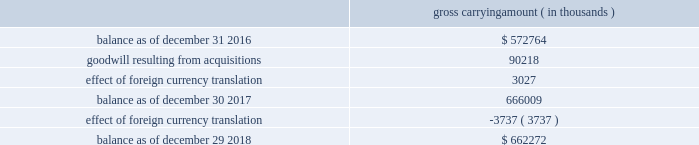Note 8 .
Acquisitions during fiscal 2017 , cadence completed two business combinations for total cash consideration of $ 142.8 million , after taking into account cash acquired of $ 4.2 million .
The total purchase consideration was allocated to the assets acquired and liabilities assumed based on their respective estimated fair values on the acquisition dates .
Cadence recorded a total of $ 76.4 million of acquired intangible assets ( of which $ 71.5 million represents in-process technology ) , $ 90.2 million of goodwill and $ 19.6 million of net liabilities consisting primarily of deferred tax liabilities .
Cadence will also make payments to certain employees , subject to continued employment and other performance-based conditions , through the fourth quarter of fiscal 2020 .
During fiscal 2016 , cadence completed two business combinations for total cash consideration of $ 42.4 million , after taking into account cash acquired of $ 1.8 million .
The total purchase consideration was allocated to the assets acquired and liabilities assumed based on their respective estimated fair values on the acquisition dates .
Cadence recorded a total of $ 23.6 million of goodwill , $ 23.2 million of acquired intangible assets and $ 2.6 million of net liabilities consisting primarily of deferred revenue .
Cadence will also make payments to certain employees , subject to continued employment and other conditions , through the second quarter of fiscal a trust for the benefit of the children of lip-bu tan , cadence 2019s chief executive officer ( 201cceo 201d ) and director , owned less than 3% ( 3 % ) of nusemi inc , one of the companies acquired in 2017 , and less than 2% ( 2 % ) of rocketick technologies ltd. , one of the companies acquired in 2016 .
Mr .
Tan and his wife serve as co-trustees of the trust and disclaim pecuniary and economic interest in the trust .
The board of directors of cadence reviewed the transactions and concluded that it was in the best interests of cadence to proceed with the transactions .
Mr .
Tan recused himself from the board of directors 2019 discussion of the valuation of nusemi inc and rocketick technologies ltd .
And on whether to proceed with the transactions .
Acquisition-related transaction costs there were no direct transaction costs associated with acquisitions during fiscal 2018 .
Transaction costs associated with acquisitions were $ 0.6 million and $ 1.1 million during fiscal 2017 and 2016 , respectively .
These costs consist of professional fees and administrative costs and were expensed as incurred in cadence 2019s consolidated income statements .
Note 9 .
Goodwill and acquired intangibles goodwill the changes in the carrying amount of goodwill during fiscal 2018 and 2017 were as follows : gross carrying amount ( in thousands ) .
Cadence completed its annual goodwill impairment test during the third quarter of fiscal 2018 and determined that the fair value of cadence 2019s single reporting unit substantially exceeded the carrying amount of its net assets and that no impairment existed. .
What is the percentage increase in the balance of goodwill from 2017 to 2018? 
Computations: ((662272 - 666009) / 666009)
Answer: -0.00561. Note 8 .
Acquisitions during fiscal 2017 , cadence completed two business combinations for total cash consideration of $ 142.8 million , after taking into account cash acquired of $ 4.2 million .
The total purchase consideration was allocated to the assets acquired and liabilities assumed based on their respective estimated fair values on the acquisition dates .
Cadence recorded a total of $ 76.4 million of acquired intangible assets ( of which $ 71.5 million represents in-process technology ) , $ 90.2 million of goodwill and $ 19.6 million of net liabilities consisting primarily of deferred tax liabilities .
Cadence will also make payments to certain employees , subject to continued employment and other performance-based conditions , through the fourth quarter of fiscal 2020 .
During fiscal 2016 , cadence completed two business combinations for total cash consideration of $ 42.4 million , after taking into account cash acquired of $ 1.8 million .
The total purchase consideration was allocated to the assets acquired and liabilities assumed based on their respective estimated fair values on the acquisition dates .
Cadence recorded a total of $ 23.6 million of goodwill , $ 23.2 million of acquired intangible assets and $ 2.6 million of net liabilities consisting primarily of deferred revenue .
Cadence will also make payments to certain employees , subject to continued employment and other conditions , through the second quarter of fiscal a trust for the benefit of the children of lip-bu tan , cadence 2019s chief executive officer ( 201cceo 201d ) and director , owned less than 3% ( 3 % ) of nusemi inc , one of the companies acquired in 2017 , and less than 2% ( 2 % ) of rocketick technologies ltd. , one of the companies acquired in 2016 .
Mr .
Tan and his wife serve as co-trustees of the trust and disclaim pecuniary and economic interest in the trust .
The board of directors of cadence reviewed the transactions and concluded that it was in the best interests of cadence to proceed with the transactions .
Mr .
Tan recused himself from the board of directors 2019 discussion of the valuation of nusemi inc and rocketick technologies ltd .
And on whether to proceed with the transactions .
Acquisition-related transaction costs there were no direct transaction costs associated with acquisitions during fiscal 2018 .
Transaction costs associated with acquisitions were $ 0.6 million and $ 1.1 million during fiscal 2017 and 2016 , respectively .
These costs consist of professional fees and administrative costs and were expensed as incurred in cadence 2019s consolidated income statements .
Note 9 .
Goodwill and acquired intangibles goodwill the changes in the carrying amount of goodwill during fiscal 2018 and 2017 were as follows : gross carrying amount ( in thousands ) .
Cadence completed its annual goodwill impairment test during the third quarter of fiscal 2018 and determined that the fair value of cadence 2019s single reporting unit substantially exceeded the carrying amount of its net assets and that no impairment existed. .
For acquisitions in 2017 what percentage of recorded a total acquired intangible assets was in-process technology? 
Computations: (71.5 / 76.4)
Answer: 0.93586. 